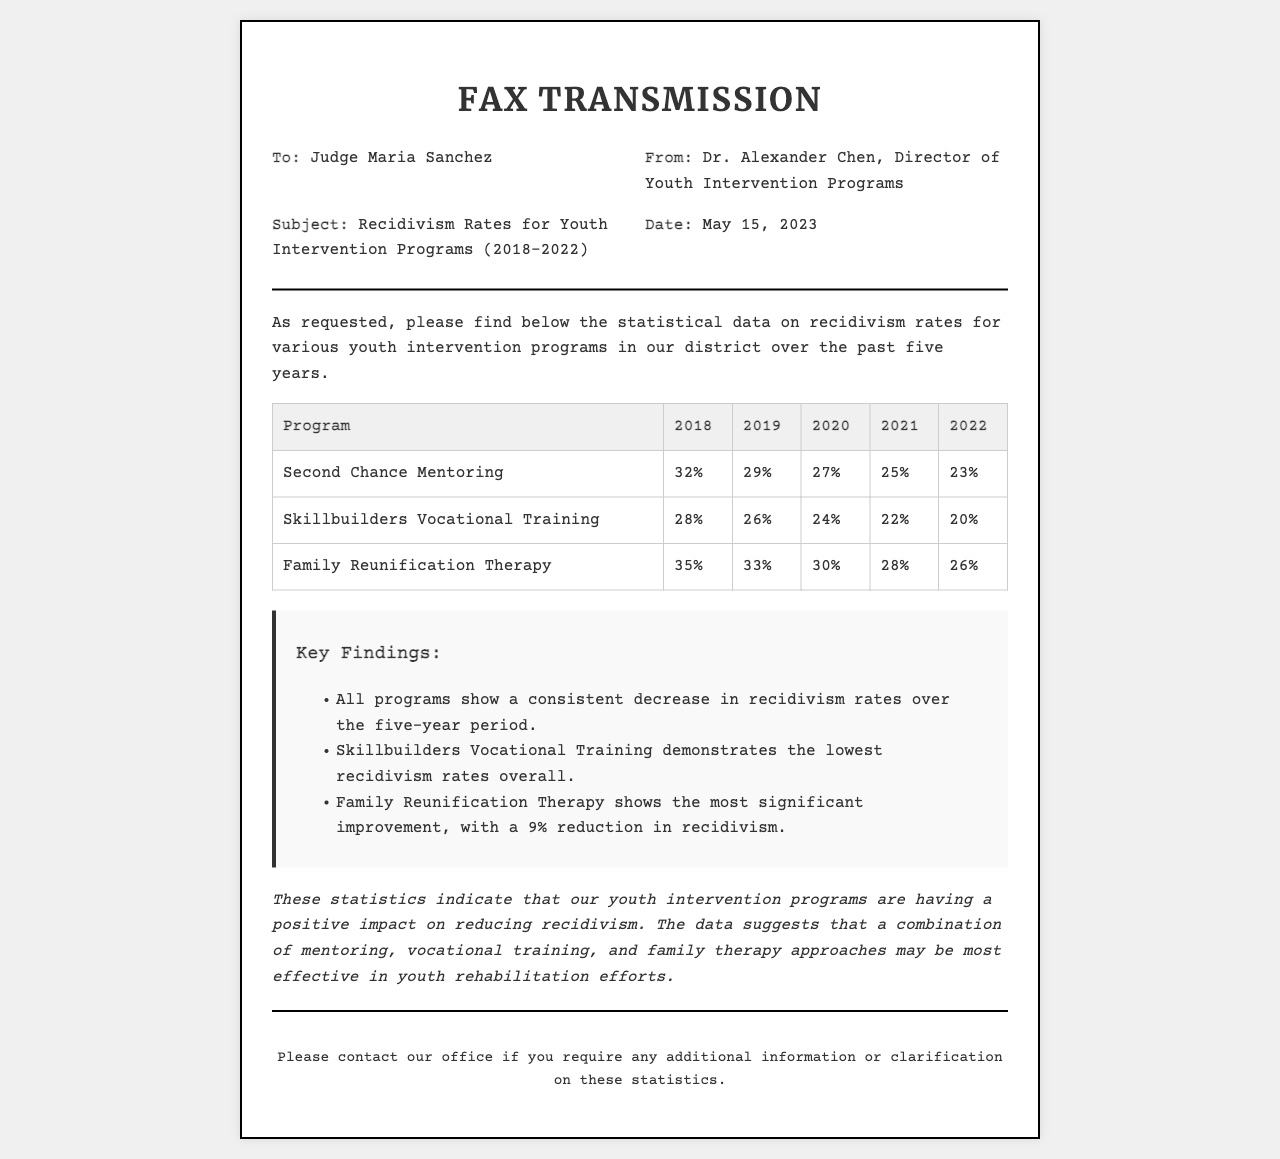What is the subject of the fax? The subject of the fax is stated in the header information, specifically regarding recidivism rates for youth intervention programs.
Answer: Recidivism Rates for Youth Intervention Programs (2018-2022) Who is the sender of the fax? The sender is identified in the header information as Dr. Alexander Chen, who is the Director of Youth Intervention Programs.
Answer: Dr. Alexander Chen What was the recidivism rate for the "Second Chance Mentoring" program in 2022? This information can be found in the program statistics table for the year 2022 under the Second Chance Mentoring row.
Answer: 23% Which program had the highest recidivism rate in 2018? The comparison of programs for the year 2018 is indicated in the table, which shows the rates for each program.
Answer: Family Reunification Therapy What trend is observed across all programs from 2018 to 2022? The key findings section summarizes the overall trends observed in the records over the five years.
Answer: Decrease in recidivism rates What is the percentage reduction in recidivism for Family Reunification Therapy from 2018 to 2022? This question requires calculation based on the statistics provided for the program in those years.
Answer: 9% What is the date of the fax? The date is provided in the header information of the document, which specifies when the fax was sent.
Answer: May 15, 2023 Which program shows the lowest recidivism rate overall? This information is contained in the key findings section that summarizes comparative data from the table.
Answer: Skillbuilders Vocational Training What is the concluding statement regarding the impact of youth intervention programs? The conclusion of the document offers an overall assessment of the program's effectiveness in reducing recidivism.
Answer: Positive impact on reducing recidivism 